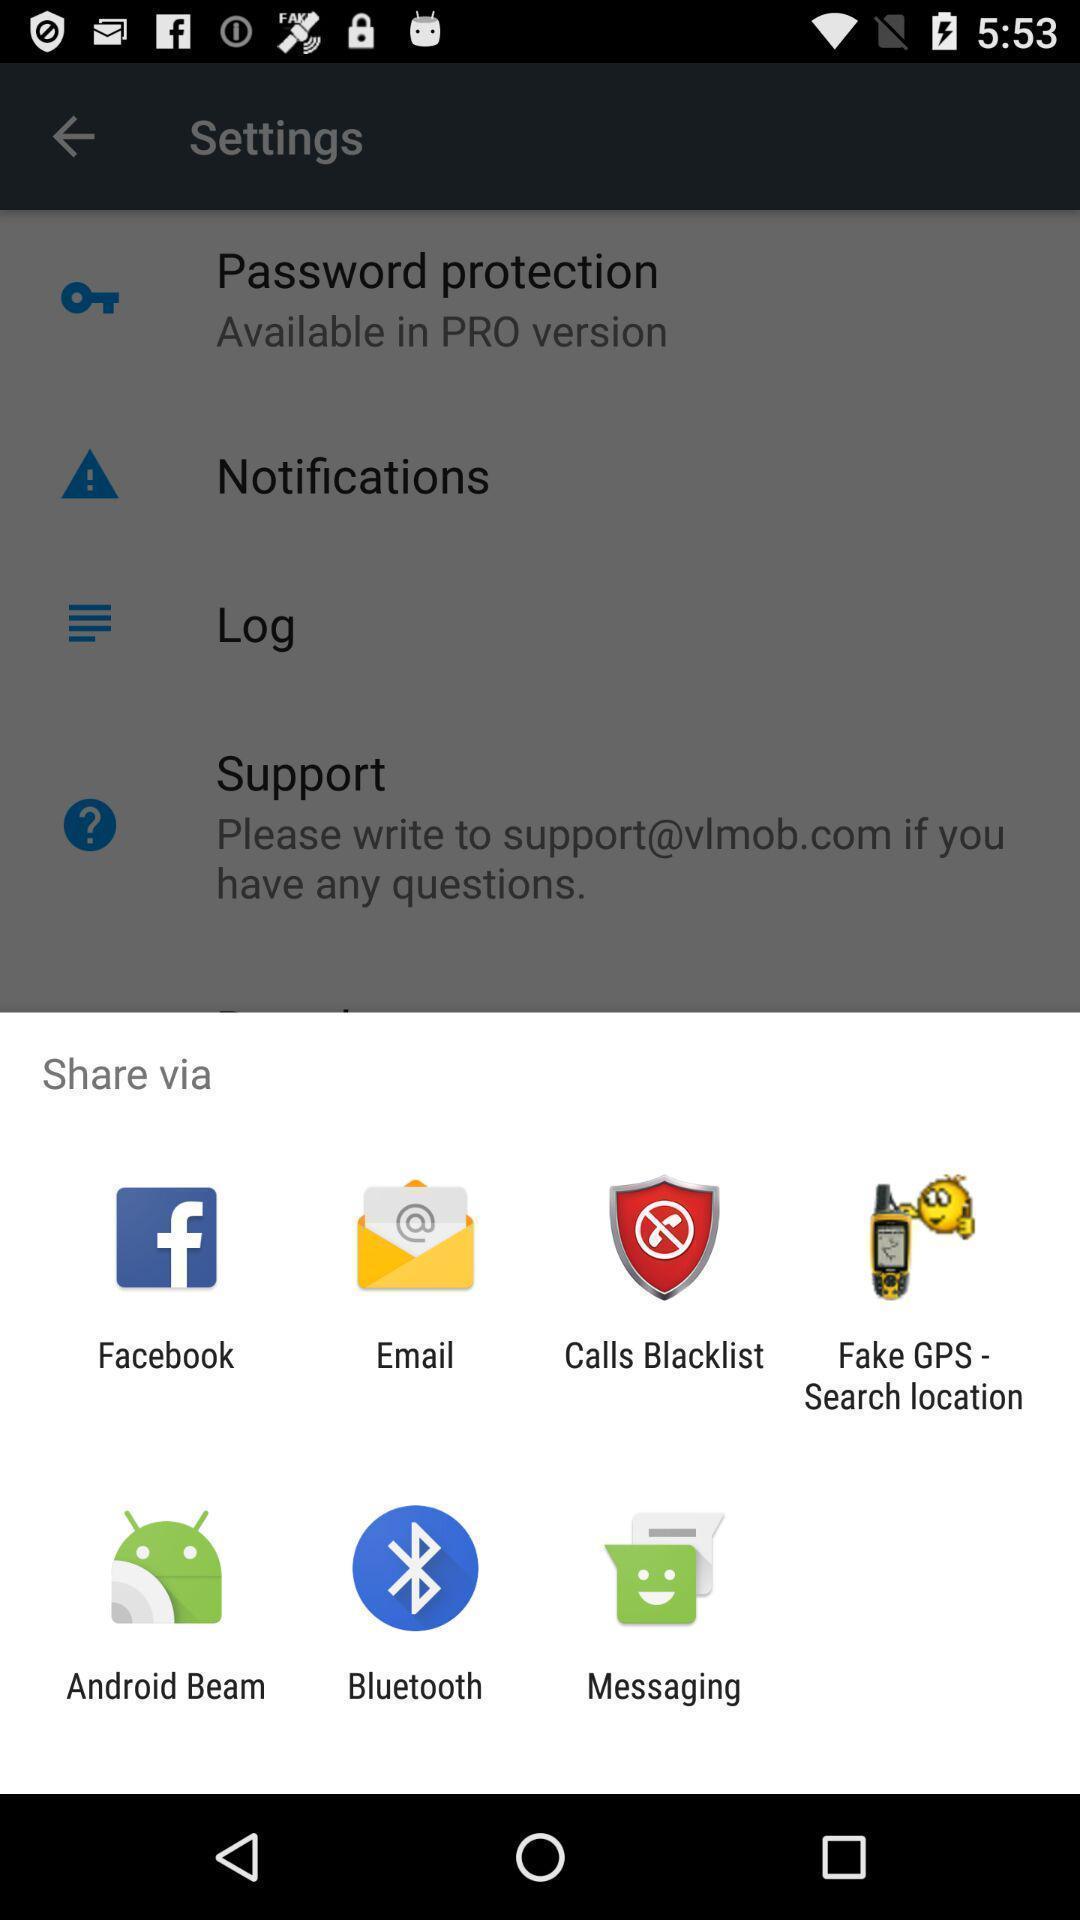Give me a narrative description of this picture. Pop-up showing different share options. 